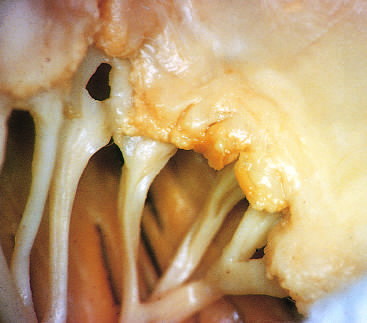where are small vegetations visible?
Answer the question using a single word or phrase. Along the line of closure of the mitral valve leaflets 